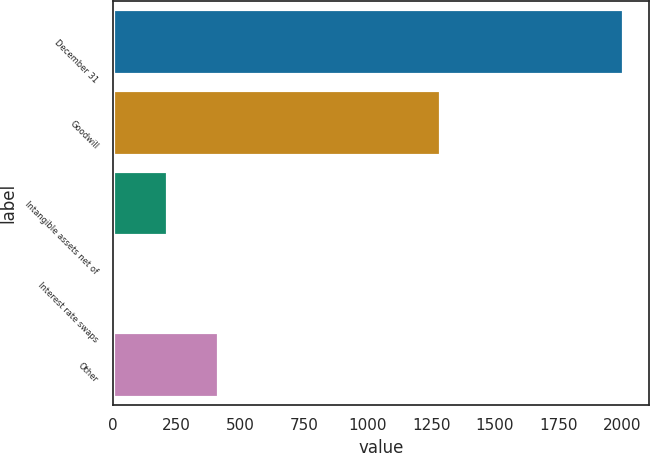<chart> <loc_0><loc_0><loc_500><loc_500><bar_chart><fcel>December 31<fcel>Goodwill<fcel>Intangible assets net of<fcel>Interest rate swaps<fcel>Other<nl><fcel>2004<fcel>1283<fcel>212<fcel>3<fcel>412.1<nl></chart> 